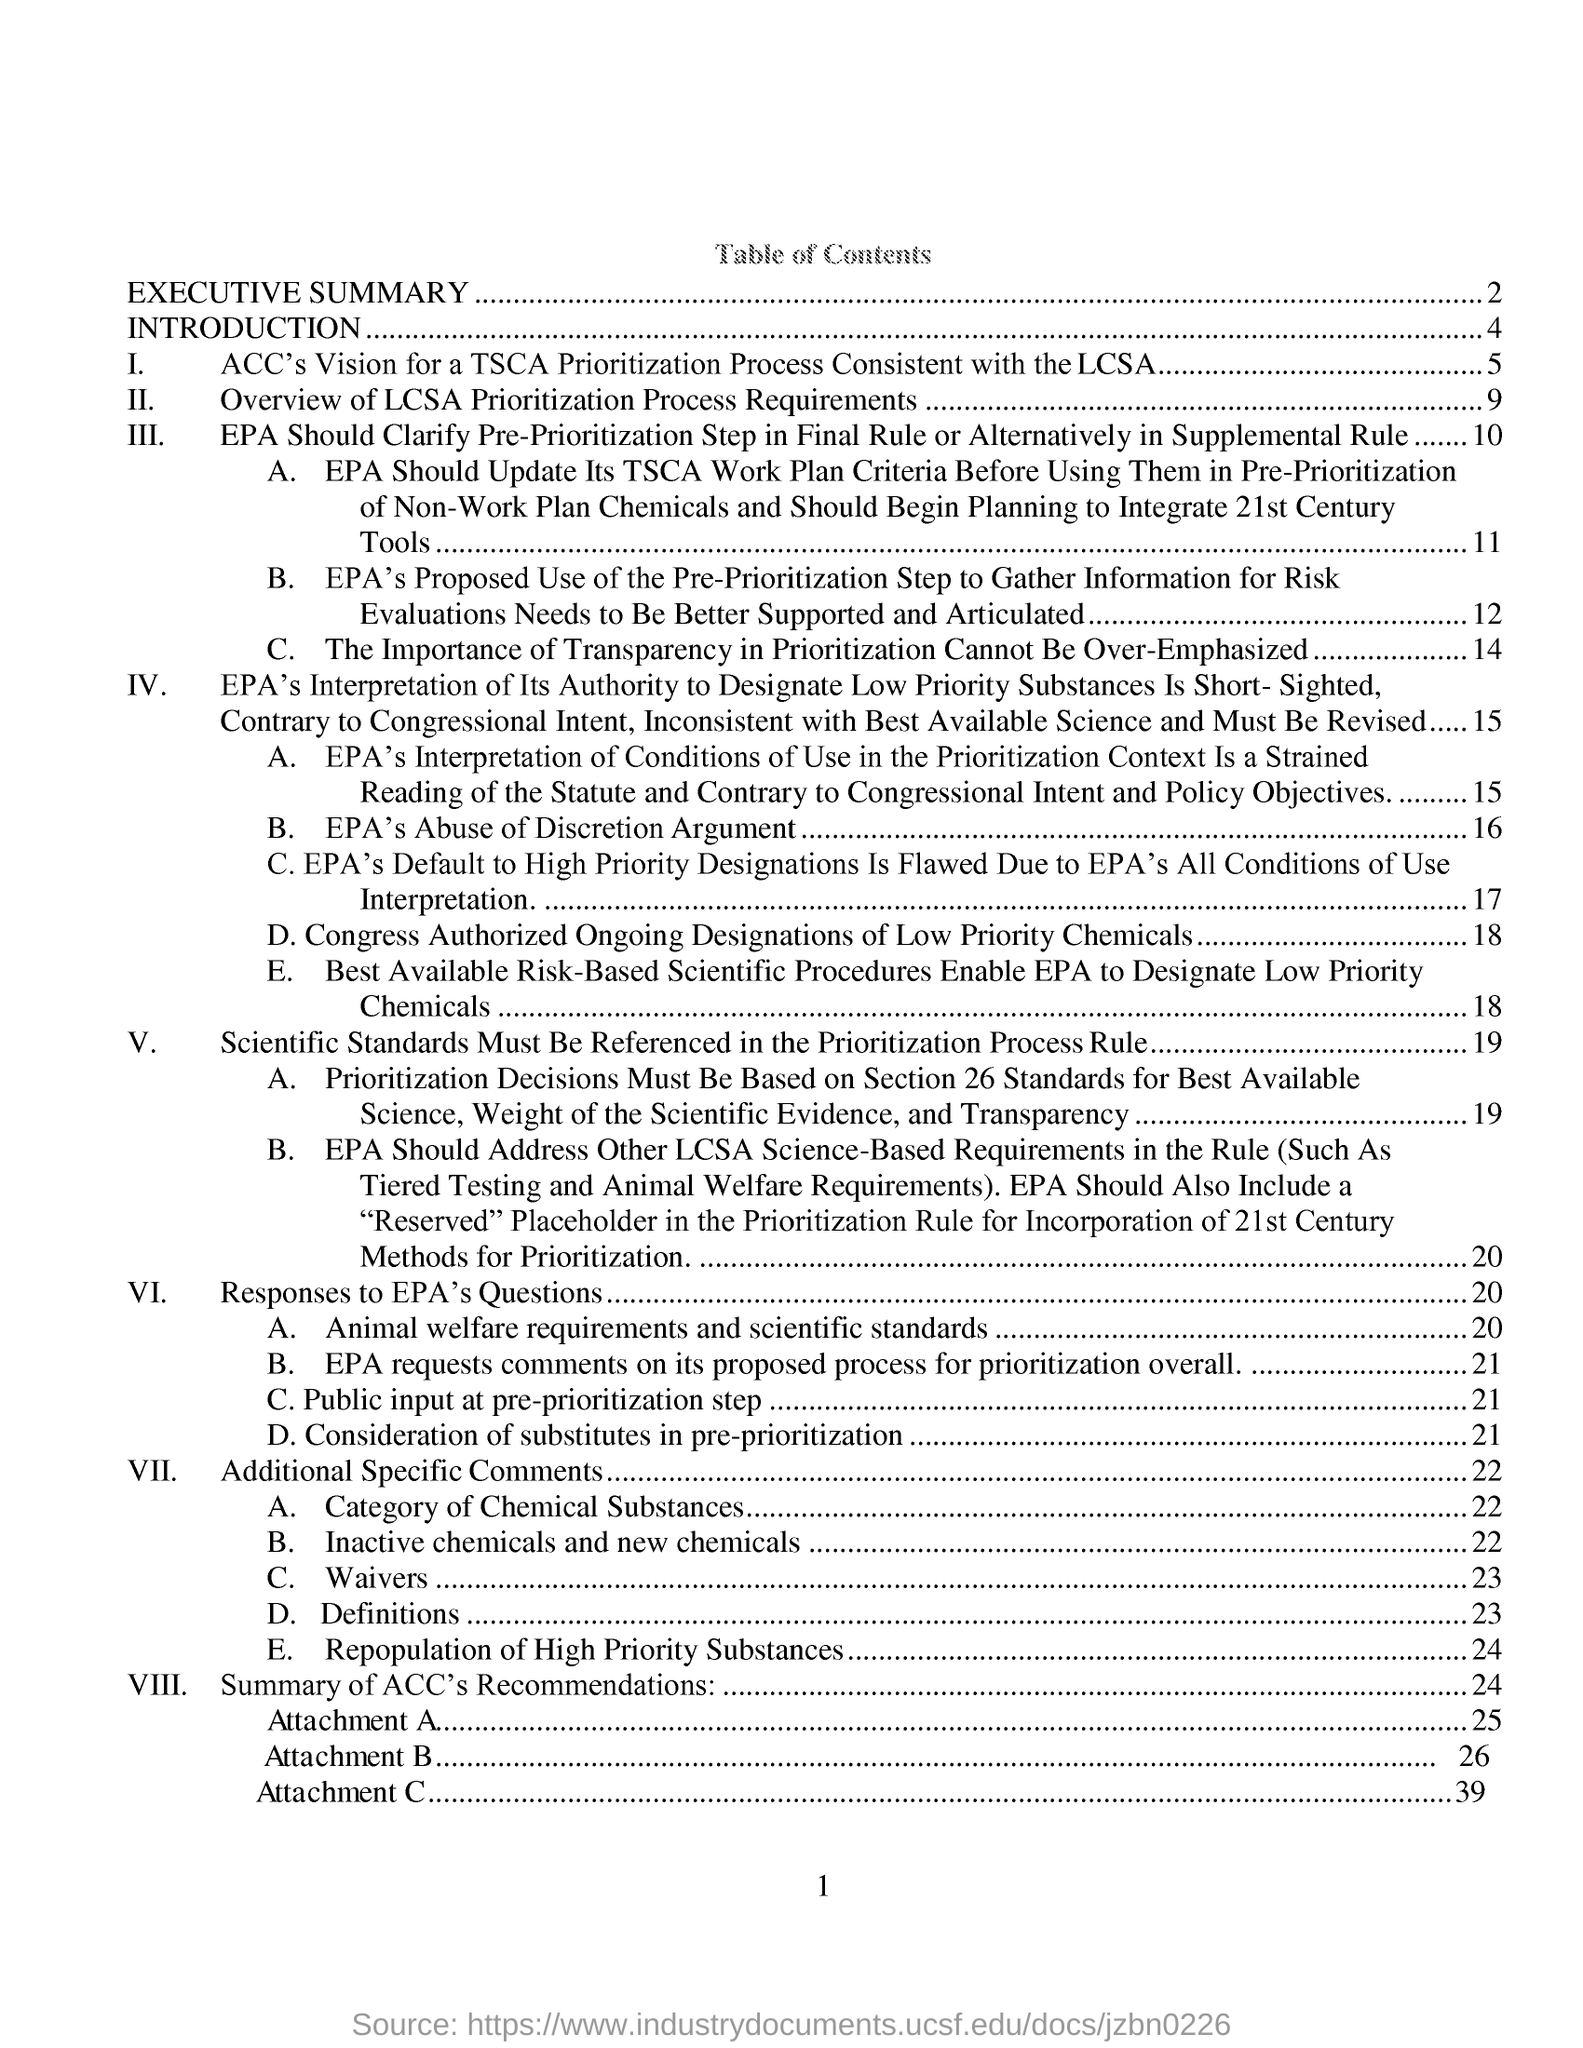What is the first topic in table of contents?
Your response must be concise. EXECUTIVE SUMMARY. What is the first topic under introduction?
Offer a very short reply. ACC'S Vision for a TSCA Prioritization Process Consistent with the LCSA. The point VII is from which page?
Offer a very short reply. Page 22. 